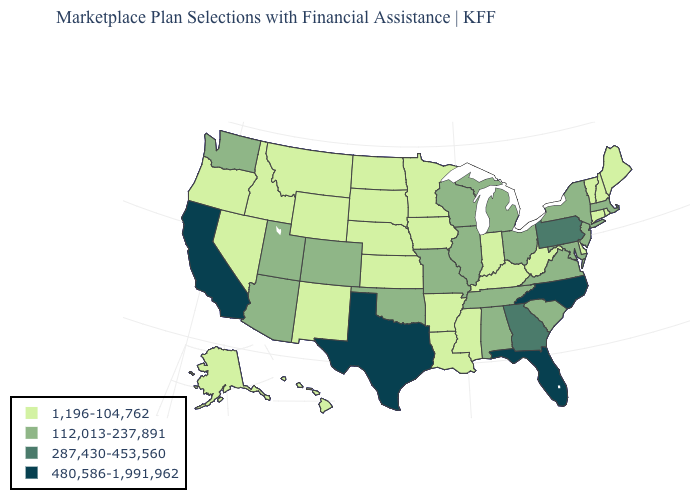Does Connecticut have the lowest value in the USA?
Write a very short answer. Yes. Which states have the highest value in the USA?
Keep it brief. California, Florida, North Carolina, Texas. Among the states that border Iowa , which have the highest value?
Quick response, please. Illinois, Missouri, Wisconsin. Does the first symbol in the legend represent the smallest category?
Concise answer only. Yes. What is the highest value in the MidWest ?
Answer briefly. 112,013-237,891. Does Hawaii have the lowest value in the West?
Quick response, please. Yes. What is the highest value in the West ?
Give a very brief answer. 480,586-1,991,962. What is the highest value in the USA?
Be succinct. 480,586-1,991,962. What is the value of Rhode Island?
Concise answer only. 1,196-104,762. Name the states that have a value in the range 480,586-1,991,962?
Answer briefly. California, Florida, North Carolina, Texas. What is the value of Rhode Island?
Short answer required. 1,196-104,762. What is the value of North Dakota?
Be succinct. 1,196-104,762. Does West Virginia have the lowest value in the USA?
Quick response, please. Yes. Name the states that have a value in the range 1,196-104,762?
Be succinct. Alaska, Arkansas, Connecticut, Delaware, Hawaii, Idaho, Indiana, Iowa, Kansas, Kentucky, Louisiana, Maine, Minnesota, Mississippi, Montana, Nebraska, Nevada, New Hampshire, New Mexico, North Dakota, Oregon, Rhode Island, South Dakota, Vermont, West Virginia, Wyoming. What is the value of Mississippi?
Answer briefly. 1,196-104,762. 